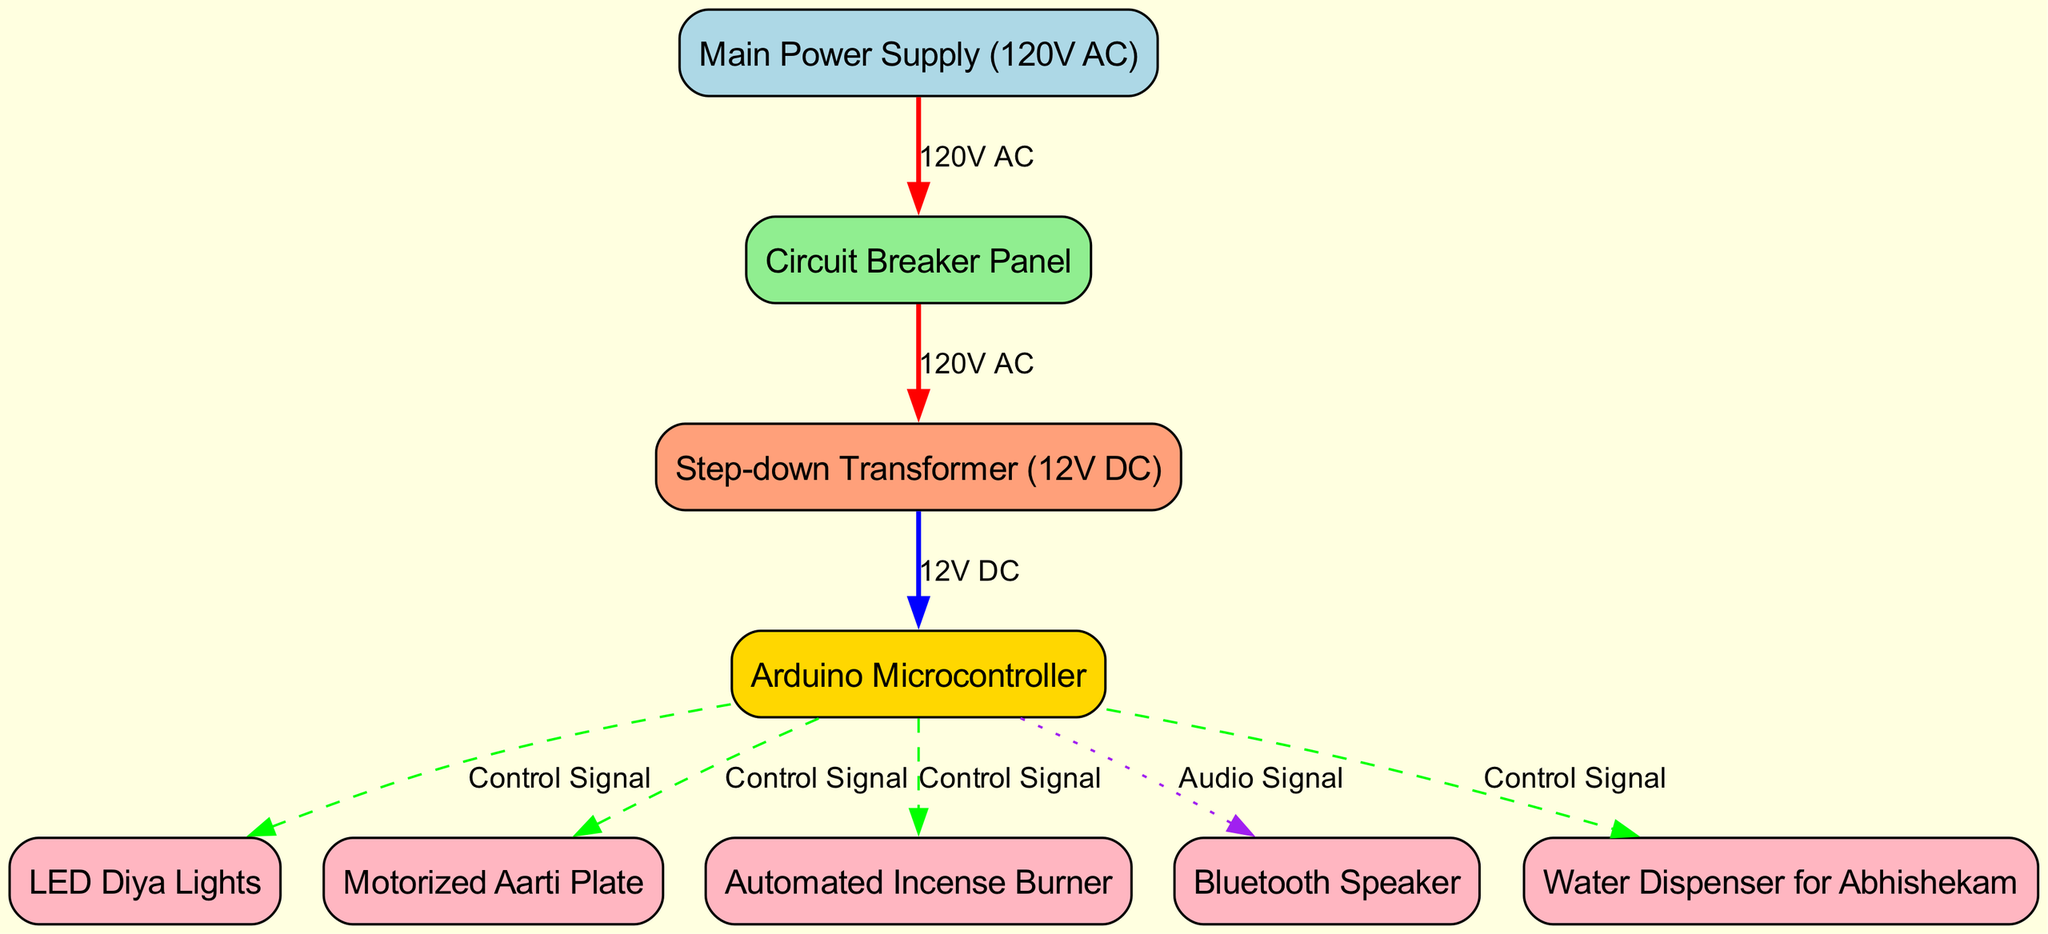What is the main power supply voltage in the diagram? The diagram indicates that the main power supply is rated at 120V AC, which is shown in the node labeled "Main Power Supply (120V AC)."
Answer: 120V AC How many nodes are present in the electrical wiring diagram? By counting the nodes listed in the diagram, we find there are 9 nodes altogether that represent various components in the system.
Answer: 9 Which component receives 12V DC from the step-down transformer? The step-down transformer (12V DC) connects directly to the Arduino Microcontroller, as indicated by the edge labeled "12V DC" between these two nodes.
Answer: Arduino Microcontroller What type of electrical signal is sent to the motorized aarti plate? The diagram specifies that the Arduino Microcontroller sends a "Control Signal" to the motorized aarti plate, as shown by the dashed edge connecting these components.
Answer: Control Signal What color is used for the edge between the circuit breaker panel and the step-down transformer? The edge from the circuit breaker panel to the step-down transformer is colored red, indicated by the label "120V AC," which represents the type of connection between these nodes.
Answer: Red Which node is responsible for controlling the LED diya lights? The Arduino Microcontroller sends a "Control Signal" to the LED diya lights, meaning it is responsible for controlling them, as shown in their connection in the diagram.
Answer: Arduino Microcontroller What connections does the Arduino Microcontroller have? The Arduino Microcontroller has five connections: to the LED diya lights, the motorized aarti plate, the automated incense burner, the Bluetooth speaker, and the water dispenser for abhishekam, all indicated as control signals except for the Bluetooth speaker which uses an audio signal.
Answer: Five connections What is the function of the step-down transformer in the diagram? The step-down transformer converts 120V AC from the circuit breaker panel to 12V DC, which is necessary for powering components like the Arduino Microcontroller, indicating its function to reduce voltage.
Answer: Convert voltage Which component is used for incense burning and connected to the Arduino? The "Automated Incense Burner" is connected to the Arduino Microcontroller with a "Control Signal," indicating that it is part of the automated system controlled by the microcontroller for puja rituals.
Answer: Automated Incense Burner 